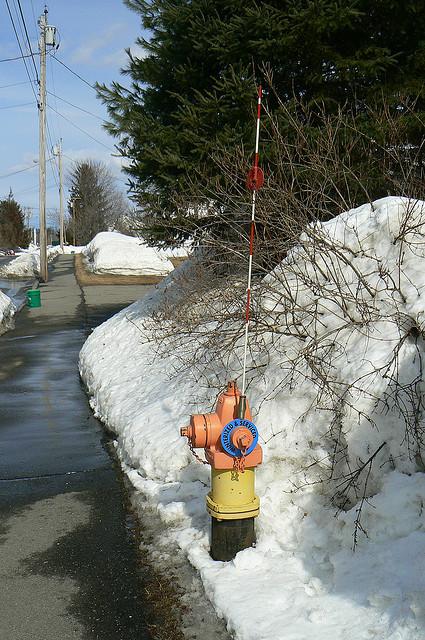Is there snow on the ground?
Be succinct. Yes. What color is the fire hydrant?
Concise answer only. Yellow. What is the green round object in the background?
Be succinct. Bucket. 